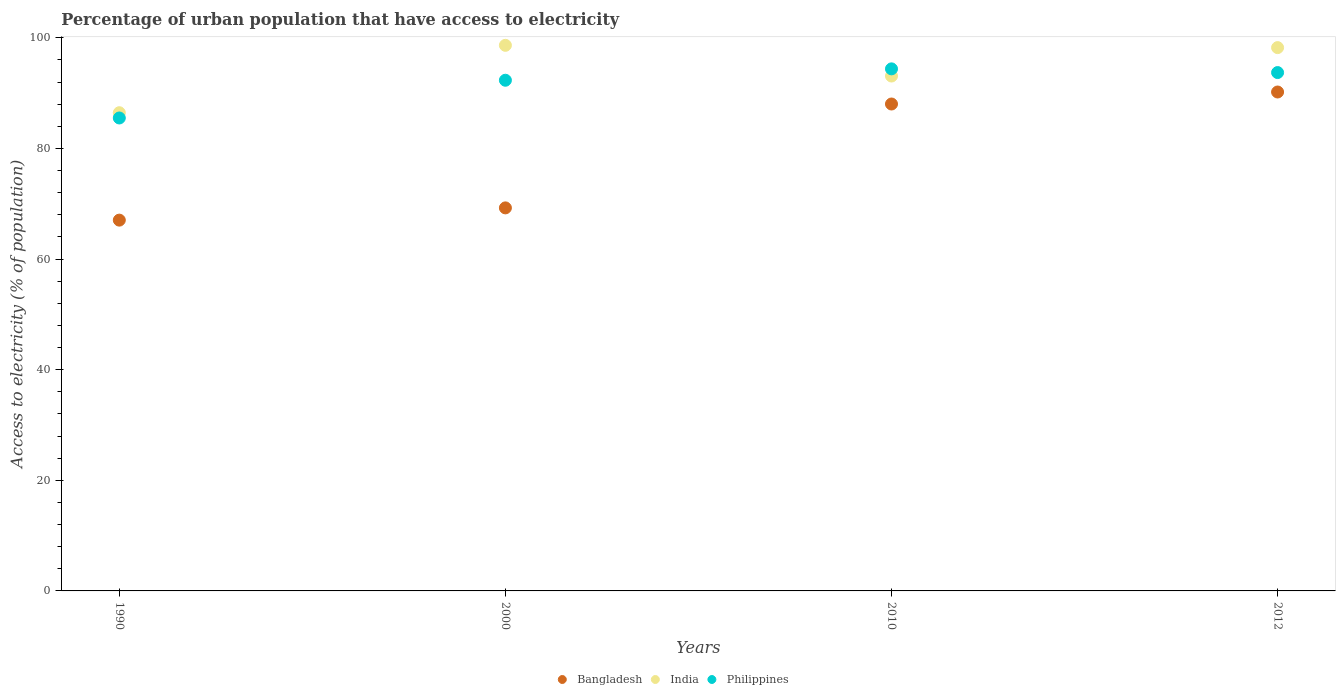How many different coloured dotlines are there?
Offer a terse response. 3. Is the number of dotlines equal to the number of legend labels?
Offer a terse response. Yes. What is the percentage of urban population that have access to electricity in Bangladesh in 2010?
Your response must be concise. 88.03. Across all years, what is the maximum percentage of urban population that have access to electricity in Philippines?
Make the answer very short. 94.38. Across all years, what is the minimum percentage of urban population that have access to electricity in Philippines?
Ensure brevity in your answer.  85.5. What is the total percentage of urban population that have access to electricity in Bangladesh in the graph?
Your answer should be very brief. 314.51. What is the difference between the percentage of urban population that have access to electricity in Bangladesh in 1990 and that in 2000?
Provide a short and direct response. -2.21. What is the difference between the percentage of urban population that have access to electricity in Bangladesh in 1990 and the percentage of urban population that have access to electricity in India in 2010?
Provide a short and direct response. -26.05. What is the average percentage of urban population that have access to electricity in Bangladesh per year?
Your answer should be very brief. 78.63. In the year 2012, what is the difference between the percentage of urban population that have access to electricity in Bangladesh and percentage of urban population that have access to electricity in India?
Your answer should be very brief. -8.03. What is the ratio of the percentage of urban population that have access to electricity in Philippines in 2000 to that in 2012?
Provide a short and direct response. 0.99. Is the percentage of urban population that have access to electricity in Bangladesh in 1990 less than that in 2000?
Your answer should be compact. Yes. What is the difference between the highest and the second highest percentage of urban population that have access to electricity in Philippines?
Give a very brief answer. 0.67. What is the difference between the highest and the lowest percentage of urban population that have access to electricity in India?
Make the answer very short. 12.19. Is the sum of the percentage of urban population that have access to electricity in Bangladesh in 2000 and 2010 greater than the maximum percentage of urban population that have access to electricity in Philippines across all years?
Your answer should be very brief. Yes. Is it the case that in every year, the sum of the percentage of urban population that have access to electricity in India and percentage of urban population that have access to electricity in Philippines  is greater than the percentage of urban population that have access to electricity in Bangladesh?
Your answer should be very brief. Yes. Does the percentage of urban population that have access to electricity in India monotonically increase over the years?
Provide a succinct answer. No. Is the percentage of urban population that have access to electricity in India strictly greater than the percentage of urban population that have access to electricity in Philippines over the years?
Your answer should be very brief. No. Is the percentage of urban population that have access to electricity in India strictly less than the percentage of urban population that have access to electricity in Philippines over the years?
Ensure brevity in your answer.  No. Are the values on the major ticks of Y-axis written in scientific E-notation?
Offer a terse response. No. Does the graph contain any zero values?
Keep it short and to the point. No. Where does the legend appear in the graph?
Your answer should be compact. Bottom center. What is the title of the graph?
Keep it short and to the point. Percentage of urban population that have access to electricity. Does "Mozambique" appear as one of the legend labels in the graph?
Provide a short and direct response. No. What is the label or title of the Y-axis?
Ensure brevity in your answer.  Access to electricity (% of population). What is the Access to electricity (% of population) of Bangladesh in 1990?
Provide a short and direct response. 67.04. What is the Access to electricity (% of population) of India in 1990?
Keep it short and to the point. 86.46. What is the Access to electricity (% of population) in Philippines in 1990?
Ensure brevity in your answer.  85.5. What is the Access to electricity (% of population) of Bangladesh in 2000?
Keep it short and to the point. 69.25. What is the Access to electricity (% of population) in India in 2000?
Ensure brevity in your answer.  98.64. What is the Access to electricity (% of population) of Philippines in 2000?
Provide a short and direct response. 92.33. What is the Access to electricity (% of population) in Bangladesh in 2010?
Your response must be concise. 88.03. What is the Access to electricity (% of population) in India in 2010?
Offer a very short reply. 93.09. What is the Access to electricity (% of population) in Philippines in 2010?
Provide a succinct answer. 94.38. What is the Access to electricity (% of population) of Bangladesh in 2012?
Make the answer very short. 90.2. What is the Access to electricity (% of population) in India in 2012?
Your answer should be very brief. 98.23. What is the Access to electricity (% of population) of Philippines in 2012?
Keep it short and to the point. 93.71. Across all years, what is the maximum Access to electricity (% of population) of Bangladesh?
Offer a terse response. 90.2. Across all years, what is the maximum Access to electricity (% of population) of India?
Keep it short and to the point. 98.64. Across all years, what is the maximum Access to electricity (% of population) in Philippines?
Keep it short and to the point. 94.38. Across all years, what is the minimum Access to electricity (% of population) in Bangladesh?
Provide a succinct answer. 67.04. Across all years, what is the minimum Access to electricity (% of population) of India?
Make the answer very short. 86.46. Across all years, what is the minimum Access to electricity (% of population) in Philippines?
Your response must be concise. 85.5. What is the total Access to electricity (% of population) in Bangladesh in the graph?
Your answer should be very brief. 314.51. What is the total Access to electricity (% of population) in India in the graph?
Your answer should be very brief. 376.41. What is the total Access to electricity (% of population) of Philippines in the graph?
Make the answer very short. 365.93. What is the difference between the Access to electricity (% of population) in Bangladesh in 1990 and that in 2000?
Offer a terse response. -2.21. What is the difference between the Access to electricity (% of population) of India in 1990 and that in 2000?
Keep it short and to the point. -12.19. What is the difference between the Access to electricity (% of population) in Philippines in 1990 and that in 2000?
Keep it short and to the point. -6.82. What is the difference between the Access to electricity (% of population) in Bangladesh in 1990 and that in 2010?
Ensure brevity in your answer.  -20.99. What is the difference between the Access to electricity (% of population) in India in 1990 and that in 2010?
Give a very brief answer. -6.63. What is the difference between the Access to electricity (% of population) of Philippines in 1990 and that in 2010?
Your answer should be very brief. -8.88. What is the difference between the Access to electricity (% of population) in Bangladesh in 1990 and that in 2012?
Make the answer very short. -23.16. What is the difference between the Access to electricity (% of population) of India in 1990 and that in 2012?
Keep it short and to the point. -11.77. What is the difference between the Access to electricity (% of population) in Philippines in 1990 and that in 2012?
Your response must be concise. -8.21. What is the difference between the Access to electricity (% of population) in Bangladesh in 2000 and that in 2010?
Provide a succinct answer. -18.78. What is the difference between the Access to electricity (% of population) of India in 2000 and that in 2010?
Your answer should be compact. 5.55. What is the difference between the Access to electricity (% of population) in Philippines in 2000 and that in 2010?
Make the answer very short. -2.06. What is the difference between the Access to electricity (% of population) of Bangladesh in 2000 and that in 2012?
Offer a terse response. -20.95. What is the difference between the Access to electricity (% of population) in India in 2000 and that in 2012?
Keep it short and to the point. 0.42. What is the difference between the Access to electricity (% of population) in Philippines in 2000 and that in 2012?
Your answer should be compact. -1.39. What is the difference between the Access to electricity (% of population) in Bangladesh in 2010 and that in 2012?
Provide a succinct answer. -2.17. What is the difference between the Access to electricity (% of population) in India in 2010 and that in 2012?
Give a very brief answer. -5.14. What is the difference between the Access to electricity (% of population) in Philippines in 2010 and that in 2012?
Your response must be concise. 0.67. What is the difference between the Access to electricity (% of population) in Bangladesh in 1990 and the Access to electricity (% of population) in India in 2000?
Keep it short and to the point. -31.61. What is the difference between the Access to electricity (% of population) in Bangladesh in 1990 and the Access to electricity (% of population) in Philippines in 2000?
Provide a succinct answer. -25.29. What is the difference between the Access to electricity (% of population) in India in 1990 and the Access to electricity (% of population) in Philippines in 2000?
Provide a succinct answer. -5.87. What is the difference between the Access to electricity (% of population) in Bangladesh in 1990 and the Access to electricity (% of population) in India in 2010?
Keep it short and to the point. -26.05. What is the difference between the Access to electricity (% of population) in Bangladesh in 1990 and the Access to electricity (% of population) in Philippines in 2010?
Ensure brevity in your answer.  -27.35. What is the difference between the Access to electricity (% of population) in India in 1990 and the Access to electricity (% of population) in Philippines in 2010?
Provide a short and direct response. -7.93. What is the difference between the Access to electricity (% of population) in Bangladesh in 1990 and the Access to electricity (% of population) in India in 2012?
Your response must be concise. -31.19. What is the difference between the Access to electricity (% of population) in Bangladesh in 1990 and the Access to electricity (% of population) in Philippines in 2012?
Give a very brief answer. -26.68. What is the difference between the Access to electricity (% of population) of India in 1990 and the Access to electricity (% of population) of Philippines in 2012?
Offer a very short reply. -7.26. What is the difference between the Access to electricity (% of population) in Bangladesh in 2000 and the Access to electricity (% of population) in India in 2010?
Offer a terse response. -23.84. What is the difference between the Access to electricity (% of population) of Bangladesh in 2000 and the Access to electricity (% of population) of Philippines in 2010?
Keep it short and to the point. -25.13. What is the difference between the Access to electricity (% of population) of India in 2000 and the Access to electricity (% of population) of Philippines in 2010?
Offer a terse response. 4.26. What is the difference between the Access to electricity (% of population) of Bangladesh in 2000 and the Access to electricity (% of population) of India in 2012?
Offer a very short reply. -28.98. What is the difference between the Access to electricity (% of population) of Bangladesh in 2000 and the Access to electricity (% of population) of Philippines in 2012?
Provide a short and direct response. -24.46. What is the difference between the Access to electricity (% of population) in India in 2000 and the Access to electricity (% of population) in Philippines in 2012?
Offer a terse response. 4.93. What is the difference between the Access to electricity (% of population) in Bangladesh in 2010 and the Access to electricity (% of population) in India in 2012?
Your answer should be very brief. -10.2. What is the difference between the Access to electricity (% of population) of Bangladesh in 2010 and the Access to electricity (% of population) of Philippines in 2012?
Ensure brevity in your answer.  -5.68. What is the difference between the Access to electricity (% of population) of India in 2010 and the Access to electricity (% of population) of Philippines in 2012?
Offer a terse response. -0.63. What is the average Access to electricity (% of population) in Bangladesh per year?
Your answer should be very brief. 78.63. What is the average Access to electricity (% of population) in India per year?
Ensure brevity in your answer.  94.1. What is the average Access to electricity (% of population) in Philippines per year?
Your answer should be compact. 91.48. In the year 1990, what is the difference between the Access to electricity (% of population) in Bangladesh and Access to electricity (% of population) in India?
Provide a short and direct response. -19.42. In the year 1990, what is the difference between the Access to electricity (% of population) in Bangladesh and Access to electricity (% of population) in Philippines?
Your response must be concise. -18.47. In the year 1990, what is the difference between the Access to electricity (% of population) in India and Access to electricity (% of population) in Philippines?
Your answer should be very brief. 0.95. In the year 2000, what is the difference between the Access to electricity (% of population) of Bangladesh and Access to electricity (% of population) of India?
Your answer should be compact. -29.39. In the year 2000, what is the difference between the Access to electricity (% of population) of Bangladesh and Access to electricity (% of population) of Philippines?
Offer a very short reply. -23.08. In the year 2000, what is the difference between the Access to electricity (% of population) of India and Access to electricity (% of population) of Philippines?
Offer a very short reply. 6.32. In the year 2010, what is the difference between the Access to electricity (% of population) in Bangladesh and Access to electricity (% of population) in India?
Provide a short and direct response. -5.06. In the year 2010, what is the difference between the Access to electricity (% of population) in Bangladesh and Access to electricity (% of population) in Philippines?
Offer a terse response. -6.35. In the year 2010, what is the difference between the Access to electricity (% of population) of India and Access to electricity (% of population) of Philippines?
Offer a terse response. -1.3. In the year 2012, what is the difference between the Access to electricity (% of population) of Bangladesh and Access to electricity (% of population) of India?
Your response must be concise. -8.03. In the year 2012, what is the difference between the Access to electricity (% of population) of Bangladesh and Access to electricity (% of population) of Philippines?
Your response must be concise. -3.51. In the year 2012, what is the difference between the Access to electricity (% of population) in India and Access to electricity (% of population) in Philippines?
Keep it short and to the point. 4.51. What is the ratio of the Access to electricity (% of population) in Bangladesh in 1990 to that in 2000?
Keep it short and to the point. 0.97. What is the ratio of the Access to electricity (% of population) of India in 1990 to that in 2000?
Provide a short and direct response. 0.88. What is the ratio of the Access to electricity (% of population) of Philippines in 1990 to that in 2000?
Provide a short and direct response. 0.93. What is the ratio of the Access to electricity (% of population) of Bangladesh in 1990 to that in 2010?
Your answer should be very brief. 0.76. What is the ratio of the Access to electricity (% of population) in India in 1990 to that in 2010?
Your response must be concise. 0.93. What is the ratio of the Access to electricity (% of population) in Philippines in 1990 to that in 2010?
Your answer should be compact. 0.91. What is the ratio of the Access to electricity (% of population) in Bangladesh in 1990 to that in 2012?
Ensure brevity in your answer.  0.74. What is the ratio of the Access to electricity (% of population) in India in 1990 to that in 2012?
Make the answer very short. 0.88. What is the ratio of the Access to electricity (% of population) of Philippines in 1990 to that in 2012?
Your answer should be compact. 0.91. What is the ratio of the Access to electricity (% of population) of Bangladesh in 2000 to that in 2010?
Your answer should be very brief. 0.79. What is the ratio of the Access to electricity (% of population) in India in 2000 to that in 2010?
Offer a terse response. 1.06. What is the ratio of the Access to electricity (% of population) of Philippines in 2000 to that in 2010?
Make the answer very short. 0.98. What is the ratio of the Access to electricity (% of population) in Bangladesh in 2000 to that in 2012?
Provide a succinct answer. 0.77. What is the ratio of the Access to electricity (% of population) of India in 2000 to that in 2012?
Offer a very short reply. 1. What is the ratio of the Access to electricity (% of population) in Philippines in 2000 to that in 2012?
Make the answer very short. 0.99. What is the ratio of the Access to electricity (% of population) in Bangladesh in 2010 to that in 2012?
Offer a terse response. 0.98. What is the ratio of the Access to electricity (% of population) in India in 2010 to that in 2012?
Your answer should be compact. 0.95. What is the ratio of the Access to electricity (% of population) in Philippines in 2010 to that in 2012?
Your answer should be compact. 1.01. What is the difference between the highest and the second highest Access to electricity (% of population) in Bangladesh?
Offer a terse response. 2.17. What is the difference between the highest and the second highest Access to electricity (% of population) in India?
Your answer should be very brief. 0.42. What is the difference between the highest and the second highest Access to electricity (% of population) in Philippines?
Keep it short and to the point. 0.67. What is the difference between the highest and the lowest Access to electricity (% of population) in Bangladesh?
Provide a succinct answer. 23.16. What is the difference between the highest and the lowest Access to electricity (% of population) in India?
Keep it short and to the point. 12.19. What is the difference between the highest and the lowest Access to electricity (% of population) in Philippines?
Provide a short and direct response. 8.88. 